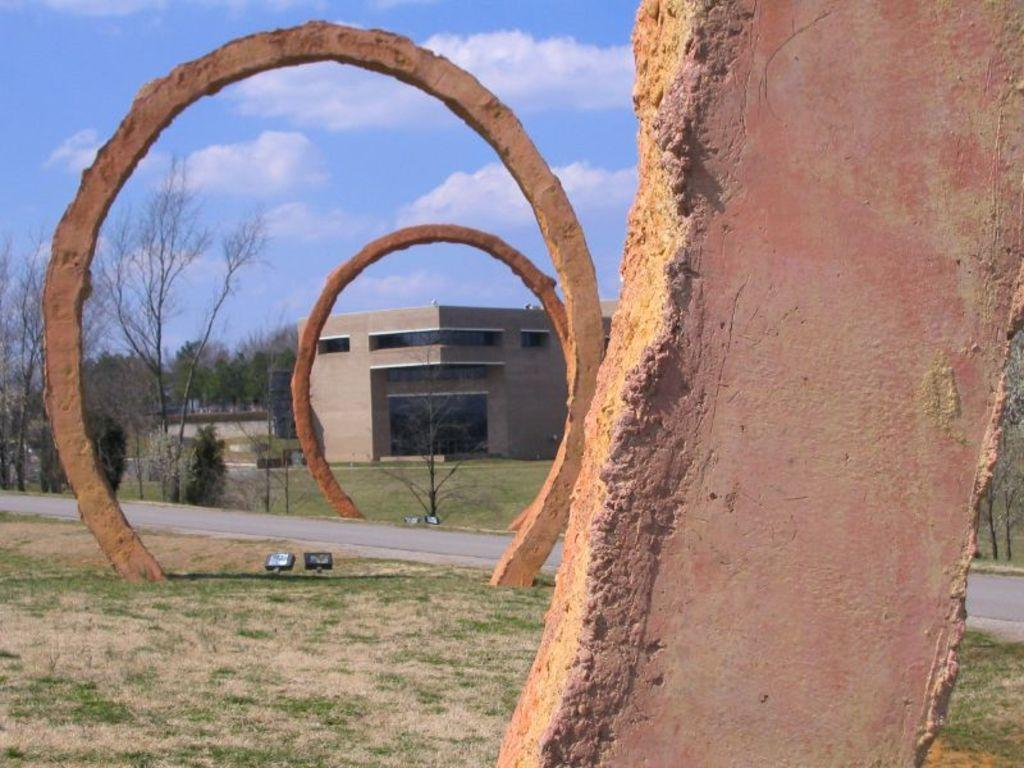What can be seen in the foreground of the picture? In the foreground of the picture, there are arches, grass, focus lights, a road, and trees. What is located in the middle of the picture? In the middle of the picture, there are trees, a building, and more grass. What is visible at the top of the picture? The sky is visible at the top of the picture. Can you see a comb being used in the picture? There is no comb present in the image. Is there a jail visible in the picture? There is no jail present in the image. 